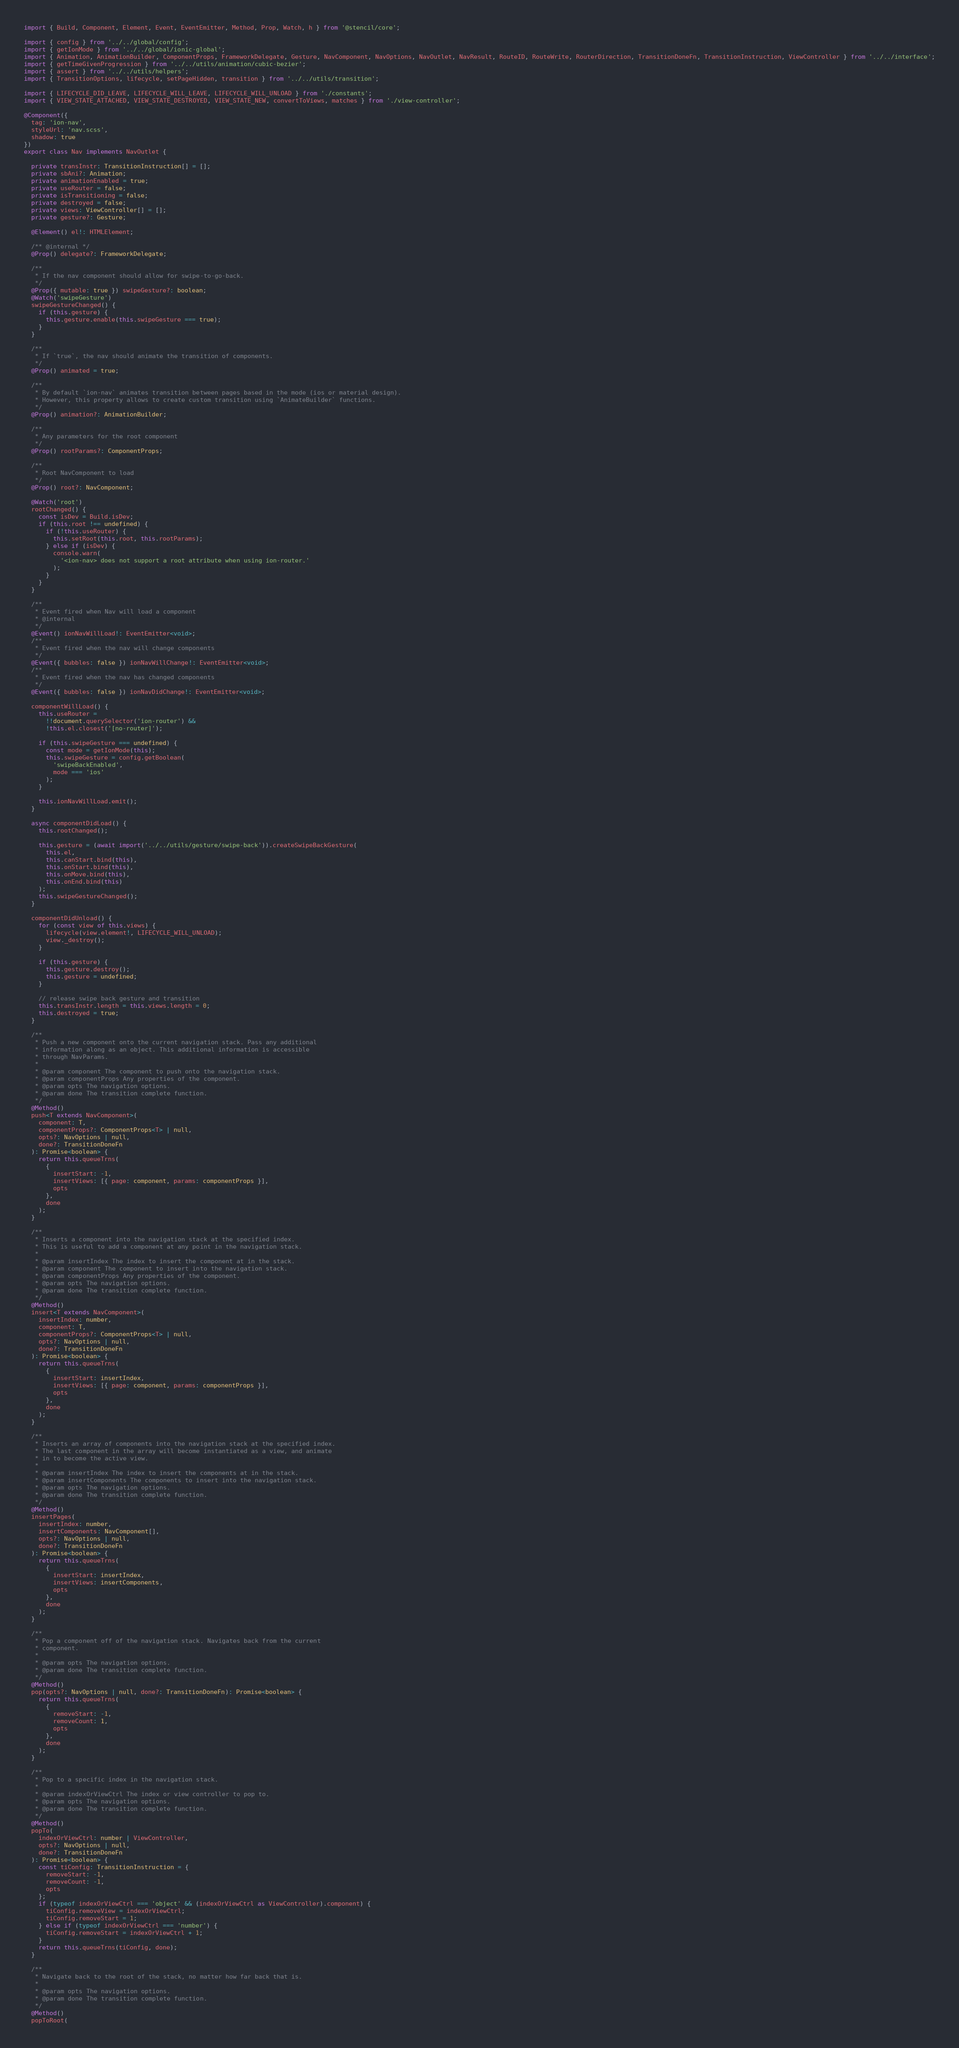<code> <loc_0><loc_0><loc_500><loc_500><_TypeScript_>import { Build, Component, Element, Event, EventEmitter, Method, Prop, Watch, h } from '@stencil/core';

import { config } from '../../global/config';
import { getIonMode } from '../../global/ionic-global';
import { Animation, AnimationBuilder, ComponentProps, FrameworkDelegate, Gesture, NavComponent, NavOptions, NavOutlet, NavResult, RouteID, RouteWrite, RouterDirection, TransitionDoneFn, TransitionInstruction, ViewController } from '../../interface';
import { getTimeGivenProgression } from '../../utils/animation/cubic-bezier';
import { assert } from '../../utils/helpers';
import { TransitionOptions, lifecycle, setPageHidden, transition } from '../../utils/transition';

import { LIFECYCLE_DID_LEAVE, LIFECYCLE_WILL_LEAVE, LIFECYCLE_WILL_UNLOAD } from './constants';
import { VIEW_STATE_ATTACHED, VIEW_STATE_DESTROYED, VIEW_STATE_NEW, convertToViews, matches } from './view-controller';

@Component({
  tag: 'ion-nav',
  styleUrl: 'nav.scss',
  shadow: true
})
export class Nav implements NavOutlet {

  private transInstr: TransitionInstruction[] = [];
  private sbAni?: Animation;
  private animationEnabled = true;
  private useRouter = false;
  private isTransitioning = false;
  private destroyed = false;
  private views: ViewController[] = [];
  private gesture?: Gesture;

  @Element() el!: HTMLElement;

  /** @internal */
  @Prop() delegate?: FrameworkDelegate;

  /**
   * If the nav component should allow for swipe-to-go-back.
   */
  @Prop({ mutable: true }) swipeGesture?: boolean;
  @Watch('swipeGesture')
  swipeGestureChanged() {
    if (this.gesture) {
      this.gesture.enable(this.swipeGesture === true);
    }
  }

  /**
   * If `true`, the nav should animate the transition of components.
   */
  @Prop() animated = true;

  /**
   * By default `ion-nav` animates transition between pages based in the mode (ios or material design).
   * However, this property allows to create custom transition using `AnimateBuilder` functions.
   */
  @Prop() animation?: AnimationBuilder;

  /**
   * Any parameters for the root component
   */
  @Prop() rootParams?: ComponentProps;

  /**
   * Root NavComponent to load
   */
  @Prop() root?: NavComponent;

  @Watch('root')
  rootChanged() {
    const isDev = Build.isDev;
    if (this.root !== undefined) {
      if (!this.useRouter) {
        this.setRoot(this.root, this.rootParams);
      } else if (isDev) {
        console.warn(
          '<ion-nav> does not support a root attribute when using ion-router.'
        );
      }
    }
  }

  /**
   * Event fired when Nav will load a component
   * @internal
   */
  @Event() ionNavWillLoad!: EventEmitter<void>;
  /**
   * Event fired when the nav will change components
   */
  @Event({ bubbles: false }) ionNavWillChange!: EventEmitter<void>;
  /**
   * Event fired when the nav has changed components
   */
  @Event({ bubbles: false }) ionNavDidChange!: EventEmitter<void>;

  componentWillLoad() {
    this.useRouter =
      !!document.querySelector('ion-router') &&
      !this.el.closest('[no-router]');

    if (this.swipeGesture === undefined) {
      const mode = getIonMode(this);
      this.swipeGesture = config.getBoolean(
        'swipeBackEnabled',
        mode === 'ios'
      );
    }

    this.ionNavWillLoad.emit();
  }

  async componentDidLoad() {
    this.rootChanged();

    this.gesture = (await import('../../utils/gesture/swipe-back')).createSwipeBackGesture(
      this.el,
      this.canStart.bind(this),
      this.onStart.bind(this),
      this.onMove.bind(this),
      this.onEnd.bind(this)
    );
    this.swipeGestureChanged();
  }

  componentDidUnload() {
    for (const view of this.views) {
      lifecycle(view.element!, LIFECYCLE_WILL_UNLOAD);
      view._destroy();
    }

    if (this.gesture) {
      this.gesture.destroy();
      this.gesture = undefined;
    }

    // release swipe back gesture and transition
    this.transInstr.length = this.views.length = 0;
    this.destroyed = true;
  }

  /**
   * Push a new component onto the current navigation stack. Pass any additional
   * information along as an object. This additional information is accessible
   * through NavParams.
   *
   * @param component The component to push onto the navigation stack.
   * @param componentProps Any properties of the component.
   * @param opts The navigation options.
   * @param done The transition complete function.
   */
  @Method()
  push<T extends NavComponent>(
    component: T,
    componentProps?: ComponentProps<T> | null,
    opts?: NavOptions | null,
    done?: TransitionDoneFn
  ): Promise<boolean> {
    return this.queueTrns(
      {
        insertStart: -1,
        insertViews: [{ page: component, params: componentProps }],
        opts
      },
      done
    );
  }

  /**
   * Inserts a component into the navigation stack at the specified index.
   * This is useful to add a component at any point in the navigation stack.
   *
   * @param insertIndex The index to insert the component at in the stack.
   * @param component The component to insert into the navigation stack.
   * @param componentProps Any properties of the component.
   * @param opts The navigation options.
   * @param done The transition complete function.
   */
  @Method()
  insert<T extends NavComponent>(
    insertIndex: number,
    component: T,
    componentProps?: ComponentProps<T> | null,
    opts?: NavOptions | null,
    done?: TransitionDoneFn
  ): Promise<boolean> {
    return this.queueTrns(
      {
        insertStart: insertIndex,
        insertViews: [{ page: component, params: componentProps }],
        opts
      },
      done
    );
  }

  /**
   * Inserts an array of components into the navigation stack at the specified index.
   * The last component in the array will become instantiated as a view, and animate
   * in to become the active view.
   *
   * @param insertIndex The index to insert the components at in the stack.
   * @param insertComponents The components to insert into the navigation stack.
   * @param opts The navigation options.
   * @param done The transition complete function.
   */
  @Method()
  insertPages(
    insertIndex: number,
    insertComponents: NavComponent[],
    opts?: NavOptions | null,
    done?: TransitionDoneFn
  ): Promise<boolean> {
    return this.queueTrns(
      {
        insertStart: insertIndex,
        insertViews: insertComponents,
        opts
      },
      done
    );
  }

  /**
   * Pop a component off of the navigation stack. Navigates back from the current
   * component.
   *
   * @param opts The navigation options.
   * @param done The transition complete function.
   */
  @Method()
  pop(opts?: NavOptions | null, done?: TransitionDoneFn): Promise<boolean> {
    return this.queueTrns(
      {
        removeStart: -1,
        removeCount: 1,
        opts
      },
      done
    );
  }

  /**
   * Pop to a specific index in the navigation stack.
   *
   * @param indexOrViewCtrl The index or view controller to pop to.
   * @param opts The navigation options.
   * @param done The transition complete function.
   */
  @Method()
  popTo(
    indexOrViewCtrl: number | ViewController,
    opts?: NavOptions | null,
    done?: TransitionDoneFn
  ): Promise<boolean> {
    const tiConfig: TransitionInstruction = {
      removeStart: -1,
      removeCount: -1,
      opts
    };
    if (typeof indexOrViewCtrl === 'object' && (indexOrViewCtrl as ViewController).component) {
      tiConfig.removeView = indexOrViewCtrl;
      tiConfig.removeStart = 1;
    } else if (typeof indexOrViewCtrl === 'number') {
      tiConfig.removeStart = indexOrViewCtrl + 1;
    }
    return this.queueTrns(tiConfig, done);
  }

  /**
   * Navigate back to the root of the stack, no matter how far back that is.
   *
   * @param opts The navigation options.
   * @param done The transition complete function.
   */
  @Method()
  popToRoot(</code> 